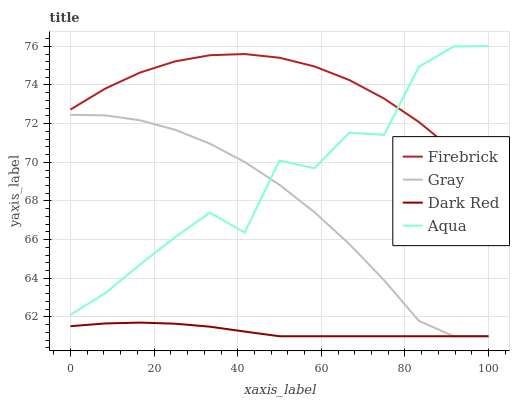Does Dark Red have the minimum area under the curve?
Answer yes or no. Yes. Does Firebrick have the maximum area under the curve?
Answer yes or no. Yes. Does Aqua have the minimum area under the curve?
Answer yes or no. No. Does Aqua have the maximum area under the curve?
Answer yes or no. No. Is Dark Red the smoothest?
Answer yes or no. Yes. Is Aqua the roughest?
Answer yes or no. Yes. Is Firebrick the smoothest?
Answer yes or no. No. Is Firebrick the roughest?
Answer yes or no. No. Does Gray have the lowest value?
Answer yes or no. Yes. Does Aqua have the lowest value?
Answer yes or no. No. Does Aqua have the highest value?
Answer yes or no. Yes. Does Firebrick have the highest value?
Answer yes or no. No. Is Dark Red less than Aqua?
Answer yes or no. Yes. Is Firebrick greater than Dark Red?
Answer yes or no. Yes. Does Gray intersect Aqua?
Answer yes or no. Yes. Is Gray less than Aqua?
Answer yes or no. No. Is Gray greater than Aqua?
Answer yes or no. No. Does Dark Red intersect Aqua?
Answer yes or no. No. 